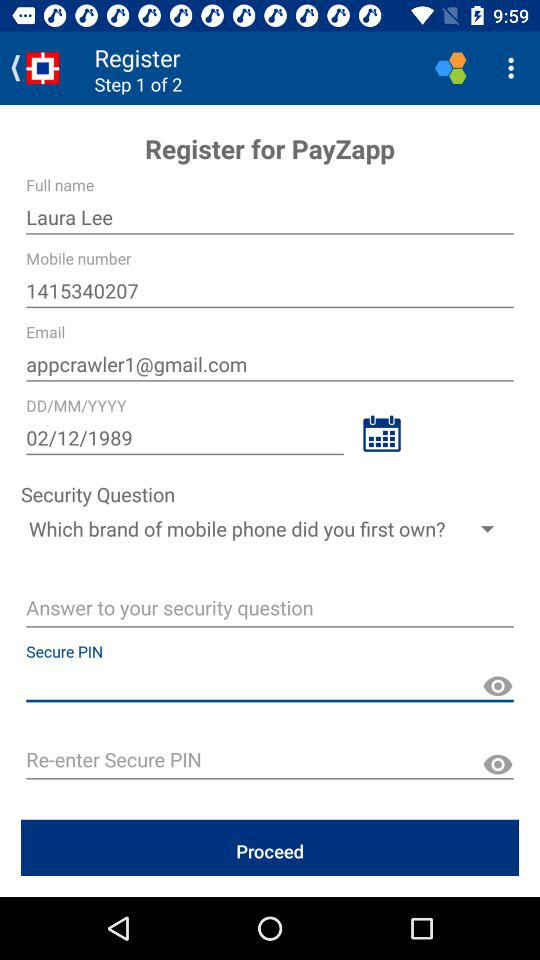What's the mobile number? The mobile number is 1415340207. 